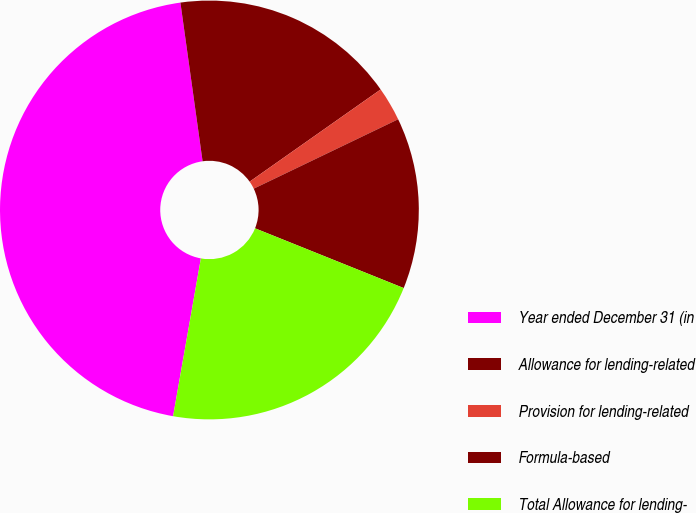<chart> <loc_0><loc_0><loc_500><loc_500><pie_chart><fcel>Year ended December 31 (in<fcel>Allowance for lending-related<fcel>Provision for lending-related<fcel>Formula-based<fcel>Total Allowance for lending-<nl><fcel>45.01%<fcel>17.45%<fcel>2.63%<fcel>13.21%<fcel>21.69%<nl></chart> 